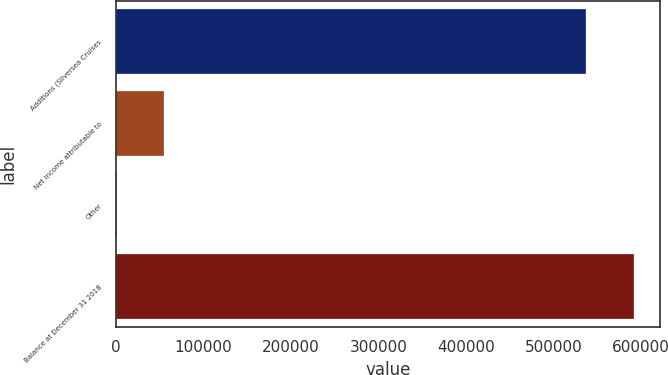Convert chart to OTSL. <chart><loc_0><loc_0><loc_500><loc_500><bar_chart><fcel>Additions (Silversea Cruises<fcel>Net income attributable to<fcel>Other<fcel>Balance at December 31 2018<nl><fcel>537770<fcel>54652<fcel>500<fcel>591922<nl></chart> 